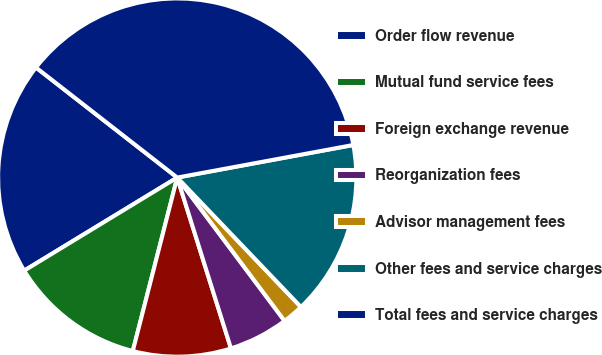<chart> <loc_0><loc_0><loc_500><loc_500><pie_chart><fcel>Order flow revenue<fcel>Mutual fund service fees<fcel>Foreign exchange revenue<fcel>Reorganization fees<fcel>Advisor management fees<fcel>Other fees and service charges<fcel>Total fees and service charges<nl><fcel>19.23%<fcel>12.31%<fcel>8.84%<fcel>5.38%<fcel>1.91%<fcel>15.77%<fcel>36.55%<nl></chart> 